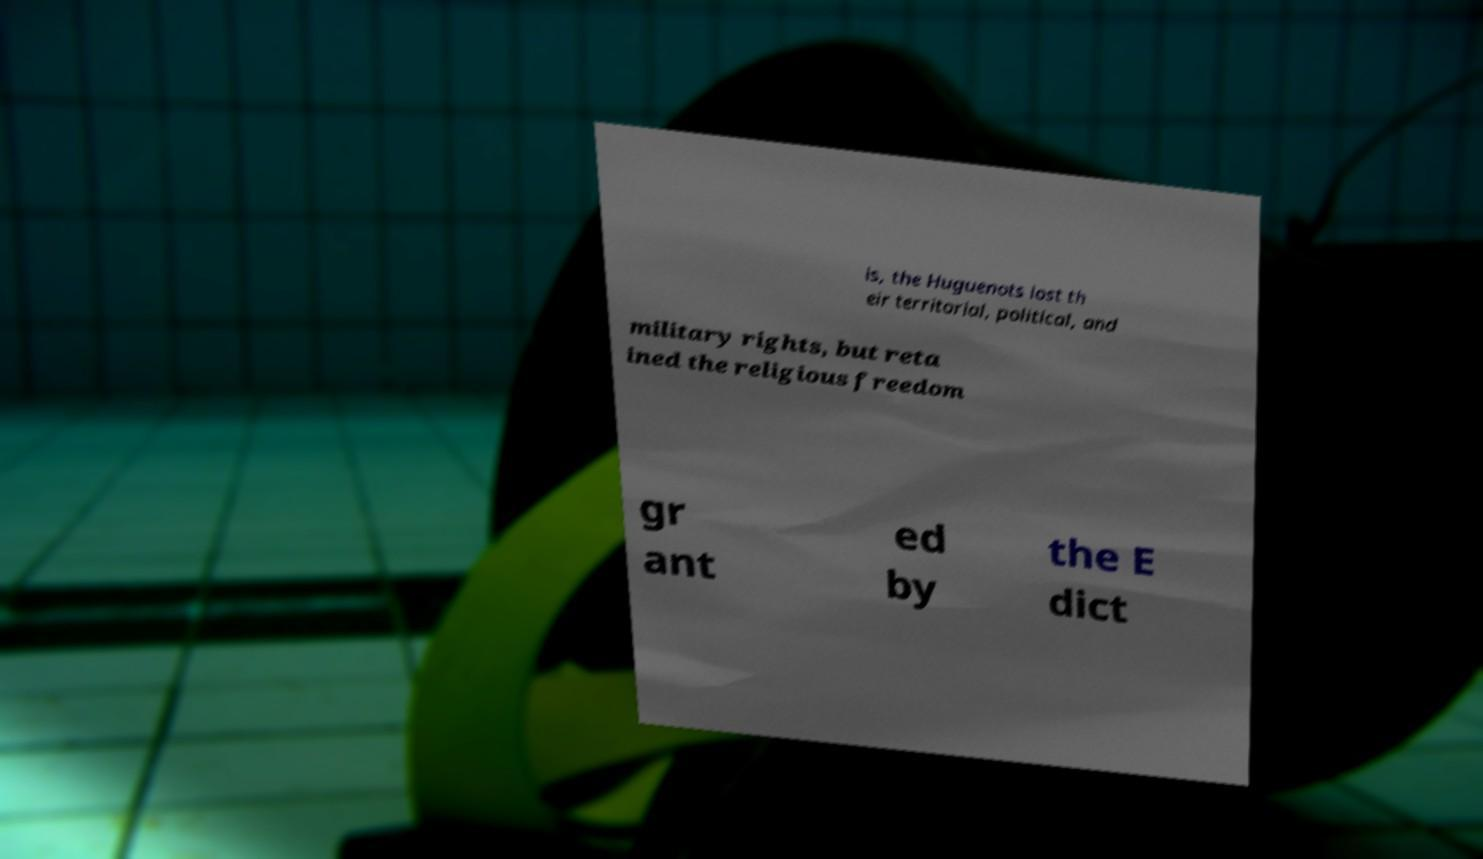What messages or text are displayed in this image? I need them in a readable, typed format. is, the Huguenots lost th eir territorial, political, and military rights, but reta ined the religious freedom gr ant ed by the E dict 